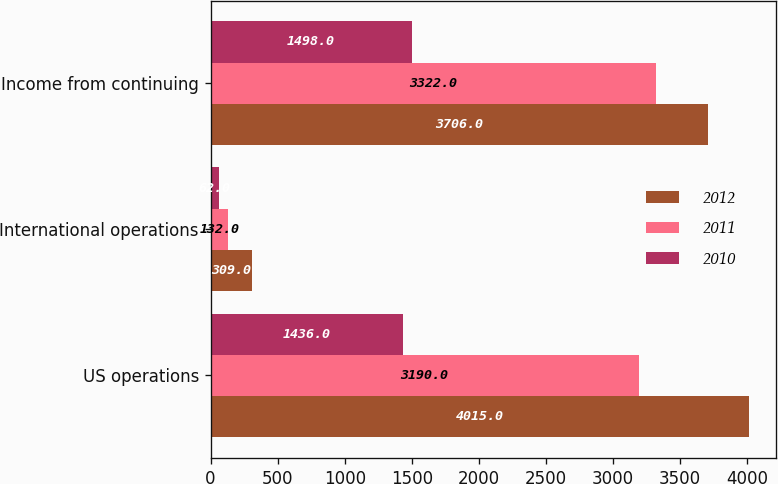<chart> <loc_0><loc_0><loc_500><loc_500><stacked_bar_chart><ecel><fcel>US operations<fcel>International operations<fcel>Income from continuing<nl><fcel>2012<fcel>4015<fcel>309<fcel>3706<nl><fcel>2011<fcel>3190<fcel>132<fcel>3322<nl><fcel>2010<fcel>1436<fcel>62<fcel>1498<nl></chart> 